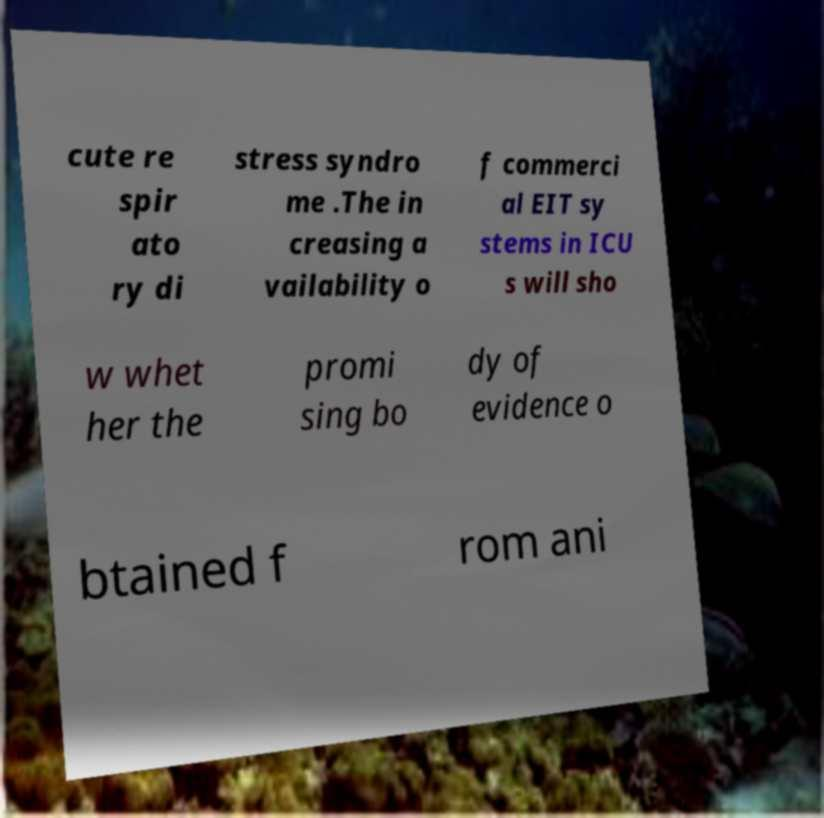For documentation purposes, I need the text within this image transcribed. Could you provide that? cute re spir ato ry di stress syndro me .The in creasing a vailability o f commerci al EIT sy stems in ICU s will sho w whet her the promi sing bo dy of evidence o btained f rom ani 